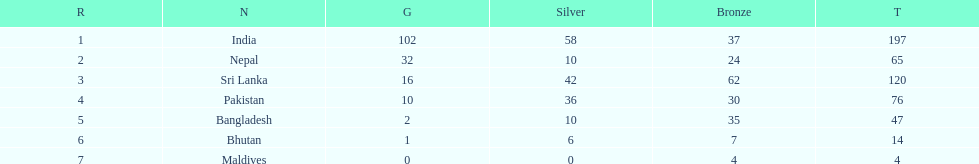What was the number of silver medals won by pakistan? 36. Help me parse the entirety of this table. {'header': ['R', 'N', 'G', 'Silver', 'Bronze', 'T'], 'rows': [['1', 'India', '102', '58', '37', '197'], ['2', 'Nepal', '32', '10', '24', '65'], ['3', 'Sri Lanka', '16', '42', '62', '120'], ['4', 'Pakistan', '10', '36', '30', '76'], ['5', 'Bangladesh', '2', '10', '35', '47'], ['6', 'Bhutan', '1', '6', '7', '14'], ['7', 'Maldives', '0', '0', '4', '4']]} 